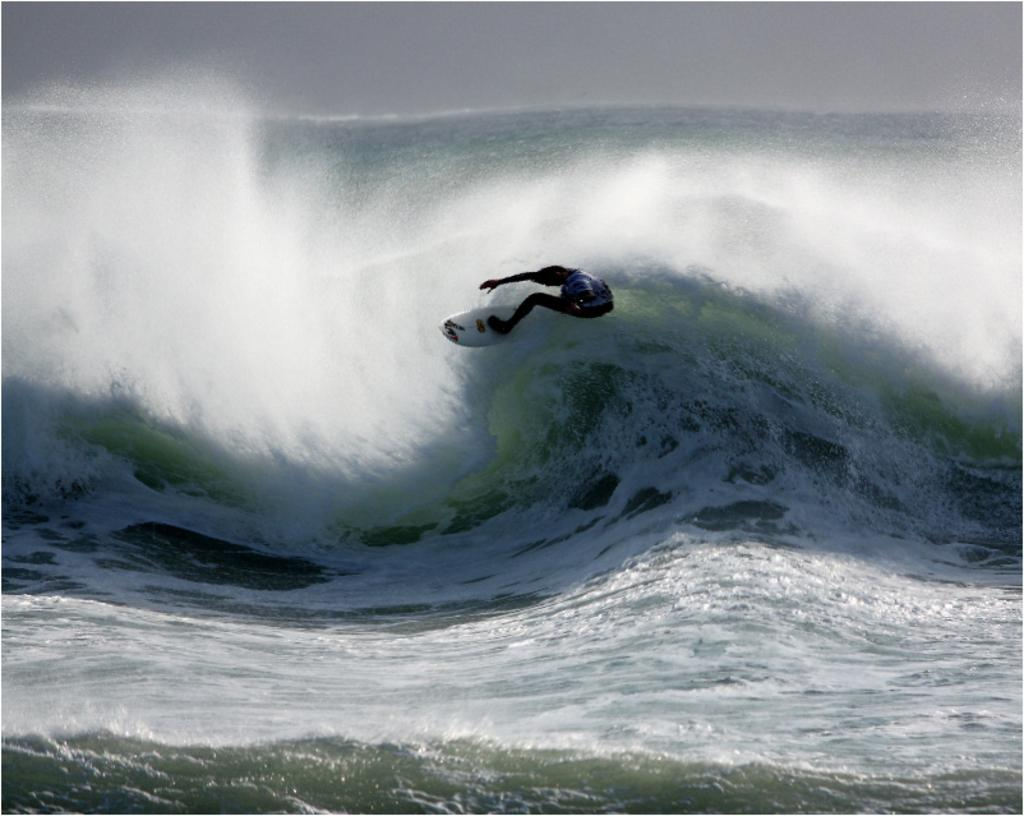What is the main subject of the image? There is a man in the image. What is the man doing in the image? The man is skateboarding. Can you describe the unique aspect of the man's skateboarding in the image? The man is skateboarding on water. What can be seen in the background of the image? There is an ocean in the background of the image. What is visible at the top of the image? The sky is visible at the top of the image. What type of tin can be seen in the image? There is no tin present in the image. Can you identify the actor in the image? There is no actor present in the image; it features a man skateboarding on water. 